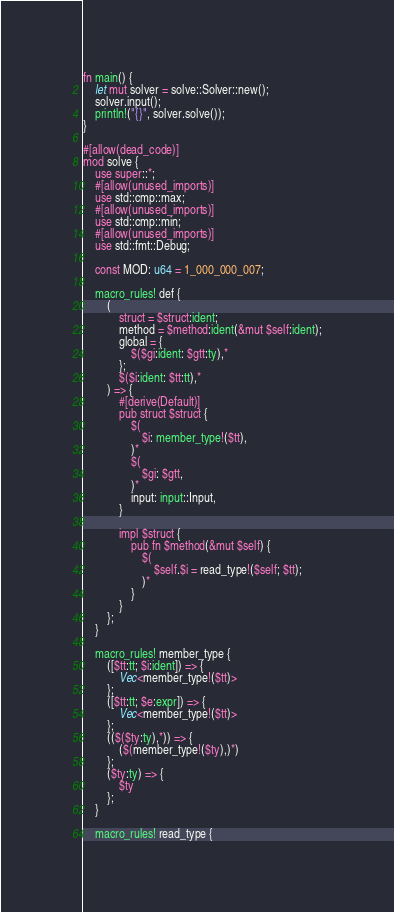<code> <loc_0><loc_0><loc_500><loc_500><_Rust_>fn main() {
	let mut solver = solve::Solver::new();
	solver.input();
	println!("{}", solver.solve());
}

#[allow(dead_code)]
mod solve {
	use super::*;
	#[allow(unused_imports)]
	use std::cmp::max;
	#[allow(unused_imports)]
	use std::cmp::min;
	#[allow(unused_imports)]
	use std::fmt::Debug;

	const MOD: u64 = 1_000_000_007;

	macro_rules! def {
		(
			struct = $struct:ident;
			method = $method:ident(&mut $self:ident);
			global = {
				$($gi:ident: $gtt:ty),*
			};
		 	$($i:ident: $tt:tt),*
		) => {
			#[derive(Default)]
			pub struct $struct {
				$(
					$i: member_type!($tt),
				)*
				$(
					$gi: $gtt,
				)*
				input: input::Input,
			}

			impl $struct {
				pub fn $method(&mut $self) {
					$(
						$self.$i = read_type!($self; $tt);
					)*
				}
			}
		};
	}

	macro_rules! member_type {
		([$tt:tt; $i:ident]) => {
			Vec<member_type!($tt)>
		};
		([$tt:tt; $e:expr]) => {
			Vec<member_type!($tt)>
		};
		(($($ty:ty),*)) => {
			($(member_type!($ty),)*)
		};
		($ty:ty) => {
			$ty
		};
	}

	macro_rules! read_type {</code> 